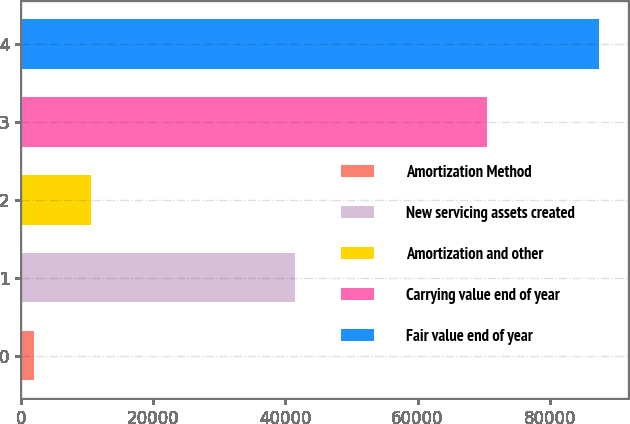<chart> <loc_0><loc_0><loc_500><loc_500><bar_chart><fcel>Amortization Method<fcel>New servicing assets created<fcel>Amortization and other<fcel>Carrying value end of year<fcel>Fair value end of year<nl><fcel>2010<fcel>41489<fcel>10555.1<fcel>70516<fcel>87461<nl></chart> 